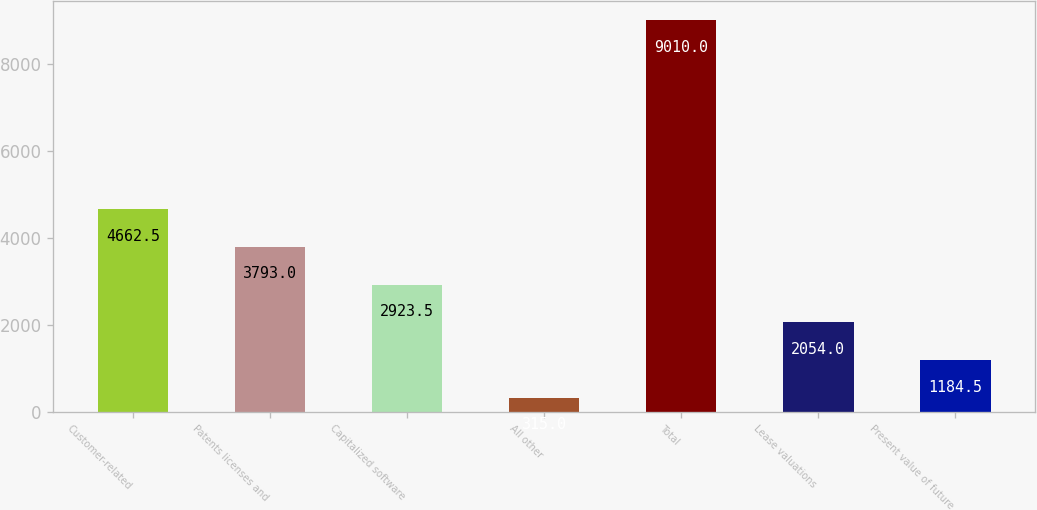<chart> <loc_0><loc_0><loc_500><loc_500><bar_chart><fcel>Customer-related<fcel>Patents licenses and<fcel>Capitalized software<fcel>All other<fcel>Total<fcel>Lease valuations<fcel>Present value of future<nl><fcel>4662.5<fcel>3793<fcel>2923.5<fcel>315<fcel>9010<fcel>2054<fcel>1184.5<nl></chart> 